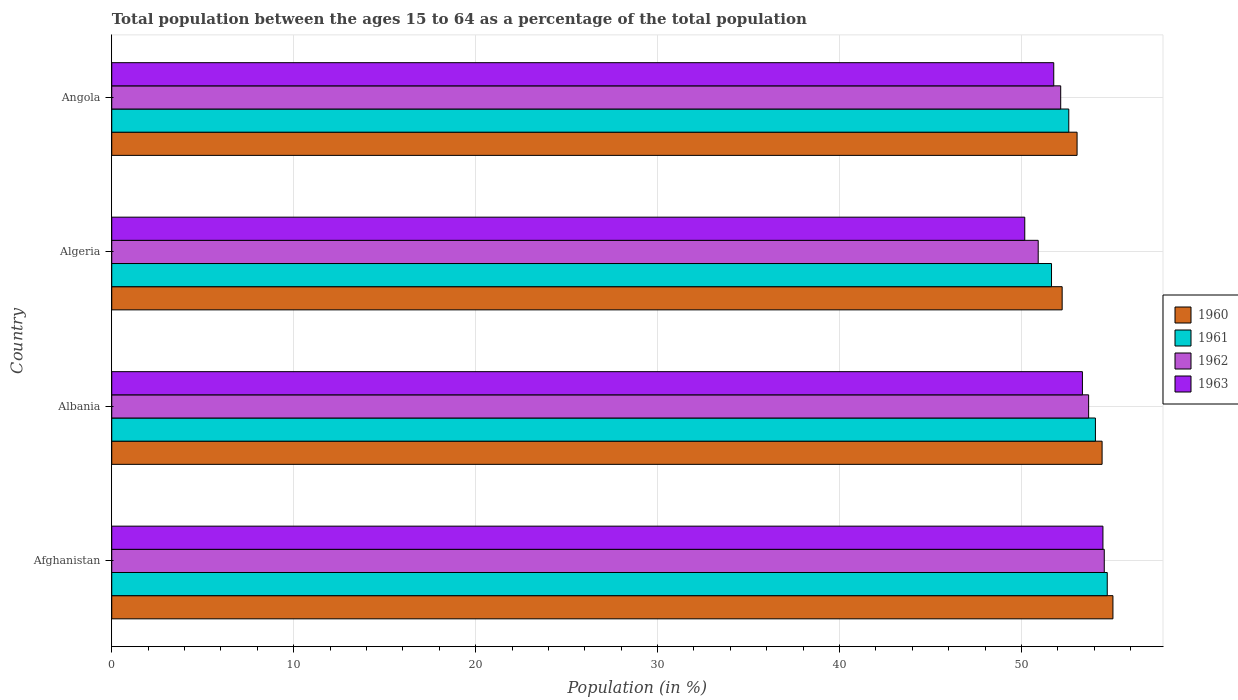How many different coloured bars are there?
Make the answer very short. 4. Are the number of bars per tick equal to the number of legend labels?
Give a very brief answer. Yes. What is the label of the 1st group of bars from the top?
Your answer should be very brief. Angola. In how many cases, is the number of bars for a given country not equal to the number of legend labels?
Your response must be concise. 0. What is the percentage of the population ages 15 to 64 in 1963 in Algeria?
Ensure brevity in your answer.  50.18. Across all countries, what is the maximum percentage of the population ages 15 to 64 in 1963?
Your answer should be very brief. 54.48. Across all countries, what is the minimum percentage of the population ages 15 to 64 in 1961?
Make the answer very short. 51.65. In which country was the percentage of the population ages 15 to 64 in 1962 maximum?
Your answer should be very brief. Afghanistan. In which country was the percentage of the population ages 15 to 64 in 1960 minimum?
Offer a terse response. Algeria. What is the total percentage of the population ages 15 to 64 in 1961 in the graph?
Make the answer very short. 213.04. What is the difference between the percentage of the population ages 15 to 64 in 1961 in Albania and that in Angola?
Your answer should be very brief. 1.46. What is the difference between the percentage of the population ages 15 to 64 in 1963 in Angola and the percentage of the population ages 15 to 64 in 1960 in Algeria?
Your answer should be compact. -0.46. What is the average percentage of the population ages 15 to 64 in 1963 per country?
Make the answer very short. 52.45. What is the difference between the percentage of the population ages 15 to 64 in 1963 and percentage of the population ages 15 to 64 in 1960 in Albania?
Provide a short and direct response. -1.08. What is the ratio of the percentage of the population ages 15 to 64 in 1963 in Afghanistan to that in Angola?
Your response must be concise. 1.05. Is the difference between the percentage of the population ages 15 to 64 in 1963 in Algeria and Angola greater than the difference between the percentage of the population ages 15 to 64 in 1960 in Algeria and Angola?
Offer a terse response. No. What is the difference between the highest and the second highest percentage of the population ages 15 to 64 in 1962?
Keep it short and to the point. 0.86. What is the difference between the highest and the lowest percentage of the population ages 15 to 64 in 1960?
Provide a short and direct response. 2.79. Is it the case that in every country, the sum of the percentage of the population ages 15 to 64 in 1961 and percentage of the population ages 15 to 64 in 1962 is greater than the sum of percentage of the population ages 15 to 64 in 1963 and percentage of the population ages 15 to 64 in 1960?
Keep it short and to the point. No. What does the 4th bar from the top in Algeria represents?
Make the answer very short. 1960. Is it the case that in every country, the sum of the percentage of the population ages 15 to 64 in 1960 and percentage of the population ages 15 to 64 in 1961 is greater than the percentage of the population ages 15 to 64 in 1963?
Make the answer very short. Yes. How many bars are there?
Your answer should be compact. 16. Are all the bars in the graph horizontal?
Offer a terse response. Yes. Does the graph contain any zero values?
Offer a terse response. No. Does the graph contain grids?
Make the answer very short. Yes. What is the title of the graph?
Offer a terse response. Total population between the ages 15 to 64 as a percentage of the total population. Does "1999" appear as one of the legend labels in the graph?
Provide a succinct answer. No. What is the label or title of the Y-axis?
Your answer should be very brief. Country. What is the Population (in %) of 1960 in Afghanistan?
Offer a terse response. 55.03. What is the Population (in %) of 1961 in Afghanistan?
Give a very brief answer. 54.72. What is the Population (in %) in 1962 in Afghanistan?
Ensure brevity in your answer.  54.55. What is the Population (in %) in 1963 in Afghanistan?
Your answer should be compact. 54.48. What is the Population (in %) of 1960 in Albania?
Provide a succinct answer. 54.43. What is the Population (in %) of 1961 in Albania?
Offer a terse response. 54.07. What is the Population (in %) of 1962 in Albania?
Your answer should be very brief. 53.69. What is the Population (in %) in 1963 in Albania?
Offer a very short reply. 53.35. What is the Population (in %) in 1960 in Algeria?
Make the answer very short. 52.24. What is the Population (in %) in 1961 in Algeria?
Provide a short and direct response. 51.65. What is the Population (in %) in 1962 in Algeria?
Provide a short and direct response. 50.92. What is the Population (in %) of 1963 in Algeria?
Offer a very short reply. 50.18. What is the Population (in %) of 1960 in Angola?
Ensure brevity in your answer.  53.06. What is the Population (in %) in 1961 in Angola?
Offer a very short reply. 52.6. What is the Population (in %) of 1962 in Angola?
Offer a very short reply. 52.16. What is the Population (in %) in 1963 in Angola?
Your answer should be compact. 51.78. Across all countries, what is the maximum Population (in %) in 1960?
Your answer should be very brief. 55.03. Across all countries, what is the maximum Population (in %) of 1961?
Give a very brief answer. 54.72. Across all countries, what is the maximum Population (in %) of 1962?
Ensure brevity in your answer.  54.55. Across all countries, what is the maximum Population (in %) in 1963?
Ensure brevity in your answer.  54.48. Across all countries, what is the minimum Population (in %) in 1960?
Offer a terse response. 52.24. Across all countries, what is the minimum Population (in %) of 1961?
Ensure brevity in your answer.  51.65. Across all countries, what is the minimum Population (in %) of 1962?
Offer a terse response. 50.92. Across all countries, what is the minimum Population (in %) of 1963?
Your answer should be compact. 50.18. What is the total Population (in %) of 1960 in the graph?
Keep it short and to the point. 214.76. What is the total Population (in %) of 1961 in the graph?
Your answer should be very brief. 213.04. What is the total Population (in %) of 1962 in the graph?
Offer a very short reply. 211.33. What is the total Population (in %) in 1963 in the graph?
Ensure brevity in your answer.  209.8. What is the difference between the Population (in %) of 1960 in Afghanistan and that in Albania?
Your response must be concise. 0.6. What is the difference between the Population (in %) in 1961 in Afghanistan and that in Albania?
Offer a very short reply. 0.65. What is the difference between the Population (in %) of 1962 in Afghanistan and that in Albania?
Ensure brevity in your answer.  0.86. What is the difference between the Population (in %) of 1963 in Afghanistan and that in Albania?
Make the answer very short. 1.13. What is the difference between the Population (in %) of 1960 in Afghanistan and that in Algeria?
Your response must be concise. 2.79. What is the difference between the Population (in %) of 1961 in Afghanistan and that in Algeria?
Your answer should be very brief. 3.06. What is the difference between the Population (in %) in 1962 in Afghanistan and that in Algeria?
Offer a terse response. 3.63. What is the difference between the Population (in %) in 1963 in Afghanistan and that in Algeria?
Your answer should be very brief. 4.3. What is the difference between the Population (in %) in 1960 in Afghanistan and that in Angola?
Offer a very short reply. 1.97. What is the difference between the Population (in %) of 1961 in Afghanistan and that in Angola?
Provide a succinct answer. 2.11. What is the difference between the Population (in %) of 1962 in Afghanistan and that in Angola?
Your response must be concise. 2.39. What is the difference between the Population (in %) of 1963 in Afghanistan and that in Angola?
Keep it short and to the point. 2.7. What is the difference between the Population (in %) in 1960 in Albania and that in Algeria?
Offer a very short reply. 2.19. What is the difference between the Population (in %) of 1961 in Albania and that in Algeria?
Your answer should be compact. 2.41. What is the difference between the Population (in %) of 1962 in Albania and that in Algeria?
Give a very brief answer. 2.77. What is the difference between the Population (in %) of 1963 in Albania and that in Algeria?
Provide a short and direct response. 3.17. What is the difference between the Population (in %) in 1960 in Albania and that in Angola?
Give a very brief answer. 1.38. What is the difference between the Population (in %) of 1961 in Albania and that in Angola?
Ensure brevity in your answer.  1.46. What is the difference between the Population (in %) in 1962 in Albania and that in Angola?
Give a very brief answer. 1.54. What is the difference between the Population (in %) of 1963 in Albania and that in Angola?
Provide a short and direct response. 1.58. What is the difference between the Population (in %) of 1960 in Algeria and that in Angola?
Offer a terse response. -0.82. What is the difference between the Population (in %) in 1961 in Algeria and that in Angola?
Give a very brief answer. -0.95. What is the difference between the Population (in %) in 1962 in Algeria and that in Angola?
Make the answer very short. -1.24. What is the difference between the Population (in %) in 1963 in Algeria and that in Angola?
Offer a very short reply. -1.59. What is the difference between the Population (in %) in 1960 in Afghanistan and the Population (in %) in 1961 in Albania?
Your answer should be very brief. 0.96. What is the difference between the Population (in %) of 1960 in Afghanistan and the Population (in %) of 1962 in Albania?
Ensure brevity in your answer.  1.34. What is the difference between the Population (in %) in 1960 in Afghanistan and the Population (in %) in 1963 in Albania?
Provide a succinct answer. 1.68. What is the difference between the Population (in %) in 1961 in Afghanistan and the Population (in %) in 1962 in Albania?
Offer a terse response. 1.02. What is the difference between the Population (in %) in 1961 in Afghanistan and the Population (in %) in 1963 in Albania?
Give a very brief answer. 1.36. What is the difference between the Population (in %) in 1962 in Afghanistan and the Population (in %) in 1963 in Albania?
Ensure brevity in your answer.  1.2. What is the difference between the Population (in %) of 1960 in Afghanistan and the Population (in %) of 1961 in Algeria?
Give a very brief answer. 3.38. What is the difference between the Population (in %) in 1960 in Afghanistan and the Population (in %) in 1962 in Algeria?
Ensure brevity in your answer.  4.11. What is the difference between the Population (in %) of 1960 in Afghanistan and the Population (in %) of 1963 in Algeria?
Provide a succinct answer. 4.85. What is the difference between the Population (in %) in 1961 in Afghanistan and the Population (in %) in 1962 in Algeria?
Offer a terse response. 3.79. What is the difference between the Population (in %) in 1961 in Afghanistan and the Population (in %) in 1963 in Algeria?
Your answer should be very brief. 4.53. What is the difference between the Population (in %) of 1962 in Afghanistan and the Population (in %) of 1963 in Algeria?
Provide a succinct answer. 4.37. What is the difference between the Population (in %) in 1960 in Afghanistan and the Population (in %) in 1961 in Angola?
Your answer should be very brief. 2.43. What is the difference between the Population (in %) of 1960 in Afghanistan and the Population (in %) of 1962 in Angola?
Your answer should be very brief. 2.87. What is the difference between the Population (in %) of 1960 in Afghanistan and the Population (in %) of 1963 in Angola?
Give a very brief answer. 3.25. What is the difference between the Population (in %) in 1961 in Afghanistan and the Population (in %) in 1962 in Angola?
Make the answer very short. 2.56. What is the difference between the Population (in %) of 1961 in Afghanistan and the Population (in %) of 1963 in Angola?
Offer a very short reply. 2.94. What is the difference between the Population (in %) of 1962 in Afghanistan and the Population (in %) of 1963 in Angola?
Your answer should be very brief. 2.78. What is the difference between the Population (in %) in 1960 in Albania and the Population (in %) in 1961 in Algeria?
Your answer should be very brief. 2.78. What is the difference between the Population (in %) in 1960 in Albania and the Population (in %) in 1962 in Algeria?
Offer a terse response. 3.51. What is the difference between the Population (in %) of 1960 in Albania and the Population (in %) of 1963 in Algeria?
Provide a short and direct response. 4.25. What is the difference between the Population (in %) of 1961 in Albania and the Population (in %) of 1962 in Algeria?
Make the answer very short. 3.14. What is the difference between the Population (in %) of 1961 in Albania and the Population (in %) of 1963 in Algeria?
Your response must be concise. 3.88. What is the difference between the Population (in %) in 1962 in Albania and the Population (in %) in 1963 in Algeria?
Offer a very short reply. 3.51. What is the difference between the Population (in %) in 1960 in Albania and the Population (in %) in 1961 in Angola?
Keep it short and to the point. 1.83. What is the difference between the Population (in %) of 1960 in Albania and the Population (in %) of 1962 in Angola?
Your response must be concise. 2.28. What is the difference between the Population (in %) of 1960 in Albania and the Population (in %) of 1963 in Angola?
Your answer should be compact. 2.66. What is the difference between the Population (in %) in 1961 in Albania and the Population (in %) in 1962 in Angola?
Give a very brief answer. 1.91. What is the difference between the Population (in %) in 1961 in Albania and the Population (in %) in 1963 in Angola?
Your answer should be compact. 2.29. What is the difference between the Population (in %) in 1962 in Albania and the Population (in %) in 1963 in Angola?
Offer a terse response. 1.92. What is the difference between the Population (in %) of 1960 in Algeria and the Population (in %) of 1961 in Angola?
Your response must be concise. -0.36. What is the difference between the Population (in %) in 1960 in Algeria and the Population (in %) in 1962 in Angola?
Offer a very short reply. 0.08. What is the difference between the Population (in %) in 1960 in Algeria and the Population (in %) in 1963 in Angola?
Keep it short and to the point. 0.46. What is the difference between the Population (in %) of 1961 in Algeria and the Population (in %) of 1962 in Angola?
Keep it short and to the point. -0.5. What is the difference between the Population (in %) in 1961 in Algeria and the Population (in %) in 1963 in Angola?
Offer a very short reply. -0.12. What is the difference between the Population (in %) in 1962 in Algeria and the Population (in %) in 1963 in Angola?
Provide a succinct answer. -0.85. What is the average Population (in %) of 1960 per country?
Keep it short and to the point. 53.69. What is the average Population (in %) of 1961 per country?
Keep it short and to the point. 53.26. What is the average Population (in %) in 1962 per country?
Give a very brief answer. 52.83. What is the average Population (in %) in 1963 per country?
Keep it short and to the point. 52.45. What is the difference between the Population (in %) of 1960 and Population (in %) of 1961 in Afghanistan?
Make the answer very short. 0.31. What is the difference between the Population (in %) of 1960 and Population (in %) of 1962 in Afghanistan?
Offer a terse response. 0.48. What is the difference between the Population (in %) of 1960 and Population (in %) of 1963 in Afghanistan?
Offer a terse response. 0.55. What is the difference between the Population (in %) of 1961 and Population (in %) of 1962 in Afghanistan?
Give a very brief answer. 0.16. What is the difference between the Population (in %) in 1961 and Population (in %) in 1963 in Afghanistan?
Your response must be concise. 0.24. What is the difference between the Population (in %) of 1962 and Population (in %) of 1963 in Afghanistan?
Your answer should be very brief. 0.07. What is the difference between the Population (in %) in 1960 and Population (in %) in 1961 in Albania?
Your answer should be compact. 0.37. What is the difference between the Population (in %) of 1960 and Population (in %) of 1962 in Albania?
Your response must be concise. 0.74. What is the difference between the Population (in %) of 1960 and Population (in %) of 1963 in Albania?
Keep it short and to the point. 1.08. What is the difference between the Population (in %) of 1961 and Population (in %) of 1962 in Albania?
Keep it short and to the point. 0.37. What is the difference between the Population (in %) in 1961 and Population (in %) in 1963 in Albania?
Offer a very short reply. 0.71. What is the difference between the Population (in %) of 1962 and Population (in %) of 1963 in Albania?
Provide a succinct answer. 0.34. What is the difference between the Population (in %) in 1960 and Population (in %) in 1961 in Algeria?
Give a very brief answer. 0.58. What is the difference between the Population (in %) in 1960 and Population (in %) in 1962 in Algeria?
Keep it short and to the point. 1.32. What is the difference between the Population (in %) in 1960 and Population (in %) in 1963 in Algeria?
Provide a short and direct response. 2.06. What is the difference between the Population (in %) of 1961 and Population (in %) of 1962 in Algeria?
Your answer should be compact. 0.73. What is the difference between the Population (in %) in 1961 and Population (in %) in 1963 in Algeria?
Make the answer very short. 1.47. What is the difference between the Population (in %) in 1962 and Population (in %) in 1963 in Algeria?
Make the answer very short. 0.74. What is the difference between the Population (in %) in 1960 and Population (in %) in 1961 in Angola?
Keep it short and to the point. 0.46. What is the difference between the Population (in %) in 1960 and Population (in %) in 1962 in Angola?
Your answer should be very brief. 0.9. What is the difference between the Population (in %) of 1960 and Population (in %) of 1963 in Angola?
Your answer should be very brief. 1.28. What is the difference between the Population (in %) in 1961 and Population (in %) in 1962 in Angola?
Offer a terse response. 0.44. What is the difference between the Population (in %) in 1961 and Population (in %) in 1963 in Angola?
Give a very brief answer. 0.83. What is the difference between the Population (in %) in 1962 and Population (in %) in 1963 in Angola?
Offer a terse response. 0.38. What is the ratio of the Population (in %) of 1960 in Afghanistan to that in Albania?
Offer a very short reply. 1.01. What is the ratio of the Population (in %) in 1963 in Afghanistan to that in Albania?
Your answer should be very brief. 1.02. What is the ratio of the Population (in %) of 1960 in Afghanistan to that in Algeria?
Your answer should be very brief. 1.05. What is the ratio of the Population (in %) of 1961 in Afghanistan to that in Algeria?
Give a very brief answer. 1.06. What is the ratio of the Population (in %) in 1962 in Afghanistan to that in Algeria?
Ensure brevity in your answer.  1.07. What is the ratio of the Population (in %) in 1963 in Afghanistan to that in Algeria?
Ensure brevity in your answer.  1.09. What is the ratio of the Population (in %) of 1960 in Afghanistan to that in Angola?
Provide a short and direct response. 1.04. What is the ratio of the Population (in %) of 1961 in Afghanistan to that in Angola?
Your answer should be very brief. 1.04. What is the ratio of the Population (in %) in 1962 in Afghanistan to that in Angola?
Keep it short and to the point. 1.05. What is the ratio of the Population (in %) in 1963 in Afghanistan to that in Angola?
Give a very brief answer. 1.05. What is the ratio of the Population (in %) in 1960 in Albania to that in Algeria?
Provide a succinct answer. 1.04. What is the ratio of the Population (in %) of 1961 in Albania to that in Algeria?
Provide a short and direct response. 1.05. What is the ratio of the Population (in %) of 1962 in Albania to that in Algeria?
Keep it short and to the point. 1.05. What is the ratio of the Population (in %) in 1963 in Albania to that in Algeria?
Provide a succinct answer. 1.06. What is the ratio of the Population (in %) in 1960 in Albania to that in Angola?
Ensure brevity in your answer.  1.03. What is the ratio of the Population (in %) in 1961 in Albania to that in Angola?
Your response must be concise. 1.03. What is the ratio of the Population (in %) in 1962 in Albania to that in Angola?
Ensure brevity in your answer.  1.03. What is the ratio of the Population (in %) in 1963 in Albania to that in Angola?
Give a very brief answer. 1.03. What is the ratio of the Population (in %) in 1960 in Algeria to that in Angola?
Offer a very short reply. 0.98. What is the ratio of the Population (in %) of 1961 in Algeria to that in Angola?
Your answer should be compact. 0.98. What is the ratio of the Population (in %) of 1962 in Algeria to that in Angola?
Provide a succinct answer. 0.98. What is the ratio of the Population (in %) in 1963 in Algeria to that in Angola?
Your response must be concise. 0.97. What is the difference between the highest and the second highest Population (in %) of 1960?
Provide a succinct answer. 0.6. What is the difference between the highest and the second highest Population (in %) in 1961?
Keep it short and to the point. 0.65. What is the difference between the highest and the second highest Population (in %) in 1962?
Give a very brief answer. 0.86. What is the difference between the highest and the second highest Population (in %) in 1963?
Your response must be concise. 1.13. What is the difference between the highest and the lowest Population (in %) in 1960?
Offer a terse response. 2.79. What is the difference between the highest and the lowest Population (in %) in 1961?
Your answer should be compact. 3.06. What is the difference between the highest and the lowest Population (in %) in 1962?
Offer a very short reply. 3.63. What is the difference between the highest and the lowest Population (in %) in 1963?
Offer a very short reply. 4.3. 